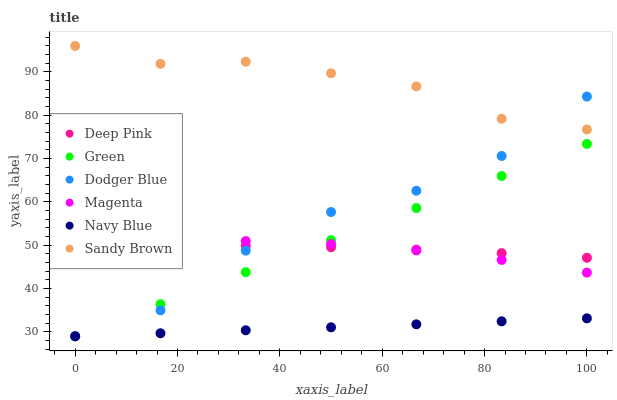Does Navy Blue have the minimum area under the curve?
Answer yes or no. Yes. Does Sandy Brown have the maximum area under the curve?
Answer yes or no. Yes. Does Dodger Blue have the minimum area under the curve?
Answer yes or no. No. Does Dodger Blue have the maximum area under the curve?
Answer yes or no. No. Is Green the smoothest?
Answer yes or no. Yes. Is Dodger Blue the roughest?
Answer yes or no. Yes. Is Navy Blue the smoothest?
Answer yes or no. No. Is Navy Blue the roughest?
Answer yes or no. No. Does Navy Blue have the lowest value?
Answer yes or no. Yes. Does Magenta have the lowest value?
Answer yes or no. No. Does Sandy Brown have the highest value?
Answer yes or no. Yes. Does Dodger Blue have the highest value?
Answer yes or no. No. Is Navy Blue less than Magenta?
Answer yes or no. Yes. Is Magenta greater than Navy Blue?
Answer yes or no. Yes. Does Dodger Blue intersect Green?
Answer yes or no. Yes. Is Dodger Blue less than Green?
Answer yes or no. No. Is Dodger Blue greater than Green?
Answer yes or no. No. Does Navy Blue intersect Magenta?
Answer yes or no. No. 